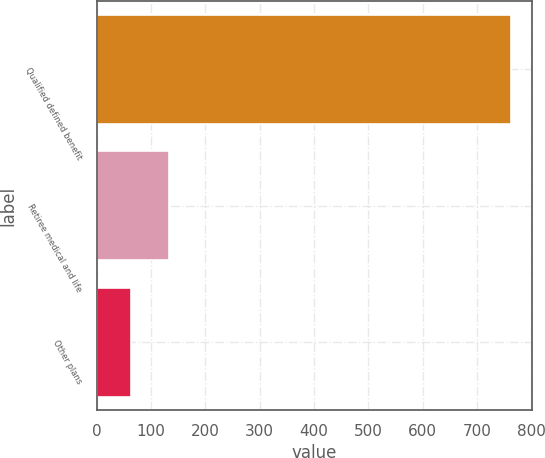Convert chart. <chart><loc_0><loc_0><loc_500><loc_500><bar_chart><fcel>Qualified defined benefit<fcel>Retiree medical and life<fcel>Other plans<nl><fcel>763<fcel>133<fcel>63<nl></chart> 